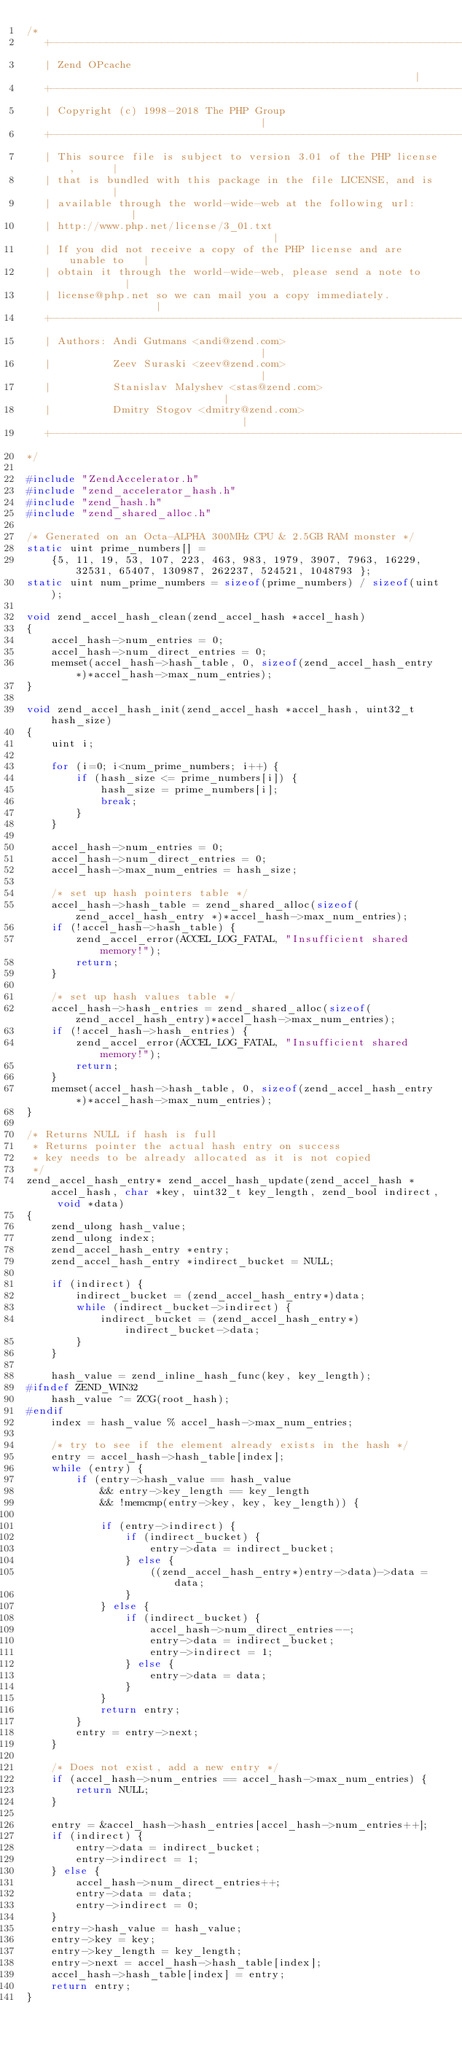<code> <loc_0><loc_0><loc_500><loc_500><_C_>/*
   +----------------------------------------------------------------------+
   | Zend OPcache                                                         |
   +----------------------------------------------------------------------+
   | Copyright (c) 1998-2018 The PHP Group                                |
   +----------------------------------------------------------------------+
   | This source file is subject to version 3.01 of the PHP license,      |
   | that is bundled with this package in the file LICENSE, and is        |
   | available through the world-wide-web at the following url:           |
   | http://www.php.net/license/3_01.txt                                  |
   | If you did not receive a copy of the PHP license and are unable to   |
   | obtain it through the world-wide-web, please send a note to          |
   | license@php.net so we can mail you a copy immediately.               |
   +----------------------------------------------------------------------+
   | Authors: Andi Gutmans <andi@zend.com>                                |
   |          Zeev Suraski <zeev@zend.com>                                |
   |          Stanislav Malyshev <stas@zend.com>                          |
   |          Dmitry Stogov <dmitry@zend.com>                             |
   +----------------------------------------------------------------------+
*/

#include "ZendAccelerator.h"
#include "zend_accelerator_hash.h"
#include "zend_hash.h"
#include "zend_shared_alloc.h"

/* Generated on an Octa-ALPHA 300MHz CPU & 2.5GB RAM monster */
static uint prime_numbers[] =
	{5, 11, 19, 53, 107, 223, 463, 983, 1979, 3907, 7963, 16229, 32531, 65407, 130987, 262237, 524521, 1048793 };
static uint num_prime_numbers = sizeof(prime_numbers) / sizeof(uint);

void zend_accel_hash_clean(zend_accel_hash *accel_hash)
{
	accel_hash->num_entries = 0;
	accel_hash->num_direct_entries = 0;
	memset(accel_hash->hash_table, 0, sizeof(zend_accel_hash_entry *)*accel_hash->max_num_entries);
}

void zend_accel_hash_init(zend_accel_hash *accel_hash, uint32_t hash_size)
{
	uint i;

	for (i=0; i<num_prime_numbers; i++) {
		if (hash_size <= prime_numbers[i]) {
			hash_size = prime_numbers[i];
			break;
		}
	}

	accel_hash->num_entries = 0;
	accel_hash->num_direct_entries = 0;
	accel_hash->max_num_entries = hash_size;

	/* set up hash pointers table */
	accel_hash->hash_table = zend_shared_alloc(sizeof(zend_accel_hash_entry *)*accel_hash->max_num_entries);
	if (!accel_hash->hash_table) {
		zend_accel_error(ACCEL_LOG_FATAL, "Insufficient shared memory!");
		return;
	}

	/* set up hash values table */
	accel_hash->hash_entries = zend_shared_alloc(sizeof(zend_accel_hash_entry)*accel_hash->max_num_entries);
	if (!accel_hash->hash_entries) {
		zend_accel_error(ACCEL_LOG_FATAL, "Insufficient shared memory!");
		return;
	}
	memset(accel_hash->hash_table, 0, sizeof(zend_accel_hash_entry *)*accel_hash->max_num_entries);
}

/* Returns NULL if hash is full
 * Returns pointer the actual hash entry on success
 * key needs to be already allocated as it is not copied
 */
zend_accel_hash_entry* zend_accel_hash_update(zend_accel_hash *accel_hash, char *key, uint32_t key_length, zend_bool indirect, void *data)
{
	zend_ulong hash_value;
	zend_ulong index;
	zend_accel_hash_entry *entry;
	zend_accel_hash_entry *indirect_bucket = NULL;

	if (indirect) {
		indirect_bucket = (zend_accel_hash_entry*)data;
		while (indirect_bucket->indirect) {
			indirect_bucket = (zend_accel_hash_entry*)indirect_bucket->data;
		}
	}

	hash_value = zend_inline_hash_func(key, key_length);
#ifndef ZEND_WIN32
	hash_value ^= ZCG(root_hash);
#endif
	index = hash_value % accel_hash->max_num_entries;

	/* try to see if the element already exists in the hash */
	entry = accel_hash->hash_table[index];
	while (entry) {
		if (entry->hash_value == hash_value
			&& entry->key_length == key_length
			&& !memcmp(entry->key, key, key_length)) {

			if (entry->indirect) {
				if (indirect_bucket) {
					entry->data = indirect_bucket;
				} else {
					((zend_accel_hash_entry*)entry->data)->data = data;
				}
			} else {
				if (indirect_bucket) {
					accel_hash->num_direct_entries--;
					entry->data = indirect_bucket;
					entry->indirect = 1;
				} else {
					entry->data = data;
				}
			}
			return entry;
		}
		entry = entry->next;
	}

	/* Does not exist, add a new entry */
	if (accel_hash->num_entries == accel_hash->max_num_entries) {
		return NULL;
	}

	entry = &accel_hash->hash_entries[accel_hash->num_entries++];
	if (indirect) {
		entry->data = indirect_bucket;
		entry->indirect = 1;
	} else {
		accel_hash->num_direct_entries++;
		entry->data = data;
		entry->indirect = 0;
	}
	entry->hash_value = hash_value;
	entry->key = key;
	entry->key_length = key_length;
	entry->next = accel_hash->hash_table[index];
	accel_hash->hash_table[index] = entry;
	return entry;
}
</code> 